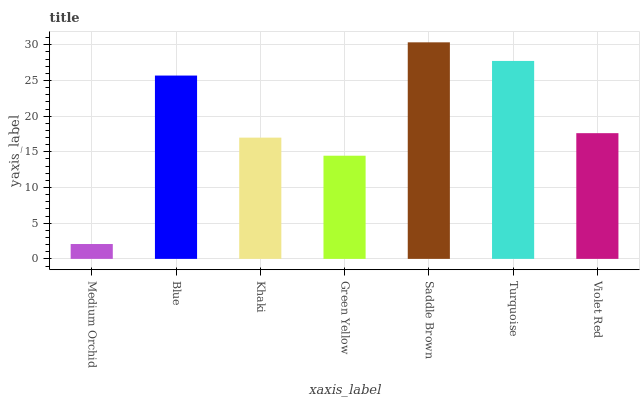Is Medium Orchid the minimum?
Answer yes or no. Yes. Is Saddle Brown the maximum?
Answer yes or no. Yes. Is Blue the minimum?
Answer yes or no. No. Is Blue the maximum?
Answer yes or no. No. Is Blue greater than Medium Orchid?
Answer yes or no. Yes. Is Medium Orchid less than Blue?
Answer yes or no. Yes. Is Medium Orchid greater than Blue?
Answer yes or no. No. Is Blue less than Medium Orchid?
Answer yes or no. No. Is Violet Red the high median?
Answer yes or no. Yes. Is Violet Red the low median?
Answer yes or no. Yes. Is Khaki the high median?
Answer yes or no. No. Is Khaki the low median?
Answer yes or no. No. 